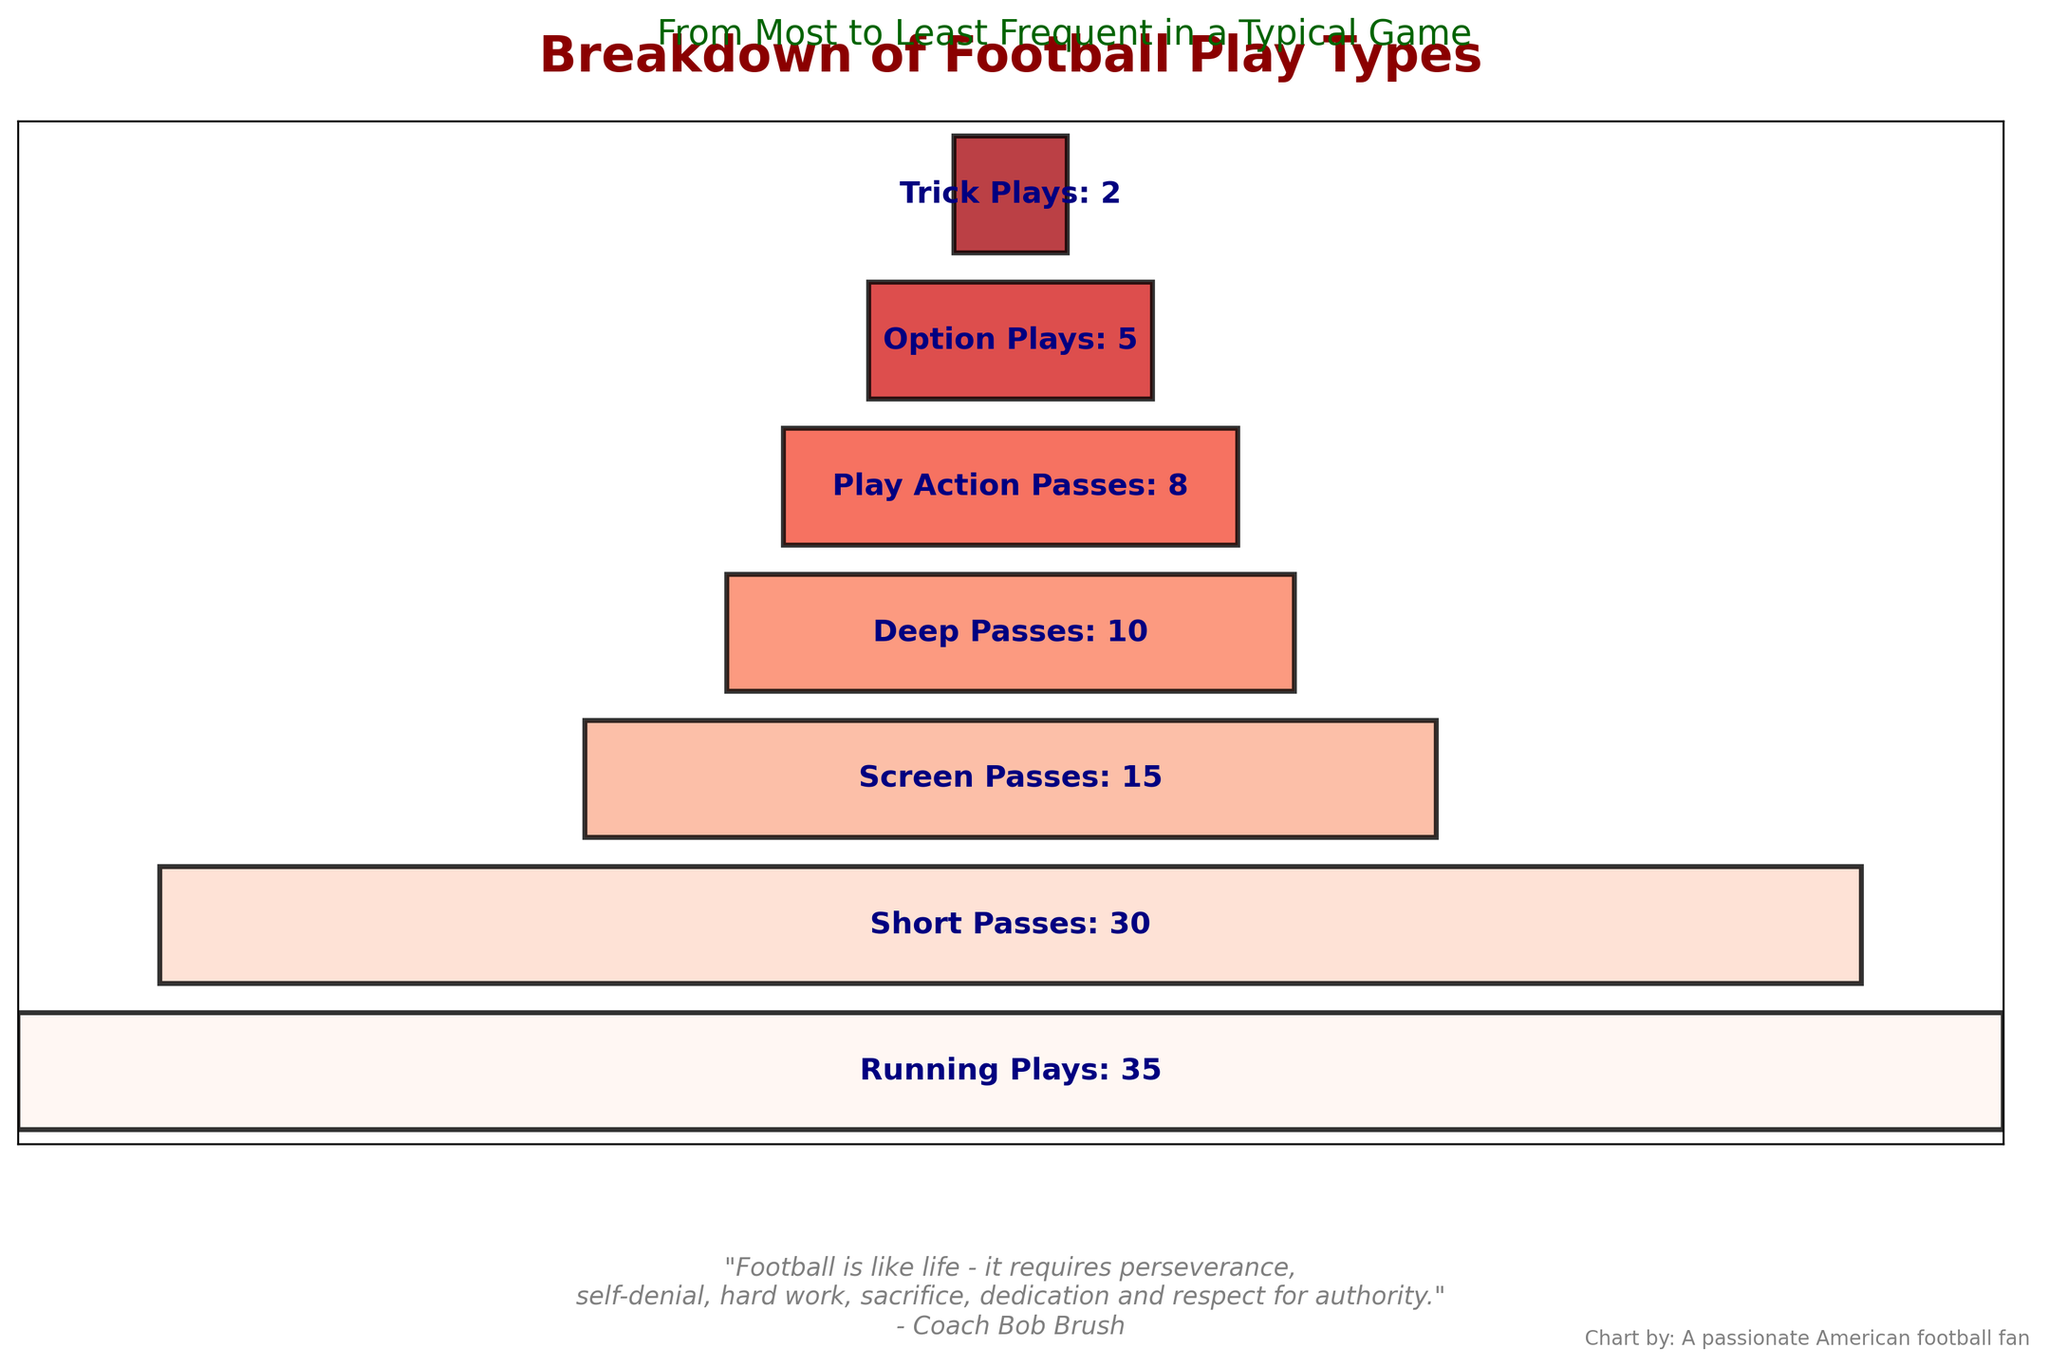What is the title of the figure? The title is usually located at the top of the figure. It reads "Breakdown of Football Play Types," which describes the types of football plays and their frequencies.
Answer: Breakdown of Football Play Types How many play types are shown in the figure? To find the number of play types shown, count the different play types listed on the funnel chart.
Answer: 7 What is the most frequent football play type called? The most frequent play type will have the widest bar at the top of the funnel chart. It is labeled as "Running Plays" with a frequency of 35.
Answer: Running Plays Which play types have a frequency lower than 10? We need to look at the funnel segments with frequencies less than 10, which are "Play Action Passes," "Option Plays," and "Trick Plays".
Answer: Play Action Passes, Option Plays, Trick Plays What is the combined frequency of Deep Passes and Short Passes? Add the frequencies of Deep Passes (10) and Short Passes (30). The combined frequency is 10 + 30.
Answer: 40 How much more frequent are Running Plays compared to Trick Plays? Subtract the frequency of Trick Plays (2) from the frequency of Running Plays (35). The difference is 35 - 2.
Answer: 33 Which play type is the third most frequent? The play types are ordered by frequency from top to bottom. The third bar from the top corresponds to "Screen Passes" with a frequency of 15.
Answer: Screen Passes How many play types are used less frequently than Short Passes? Identify the play types below Short Passes on the funnel chart: Screen Passes, Deep Passes, Play Action Passes, Option Plays, and Trick Plays. There are 5 play types in total.
Answer: 5 What is the frequency range of the play types shown? The frequency range can be calculated by subtracting the lowest frequency (Trick Plays, 2) from the highest frequency (Running Plays, 35). The range is 35 - 2.
Answer: 33 What proportion of the total plays are Running Plays? First, sum the total frequency of all play types: 35 + 30 + 15 + 10 + 8 + 5 + 2 = 105. Then, calculate the proportion of Running Plays: 35/105 ≈ 0.333 or 33.3%.
Answer: 33.3% 